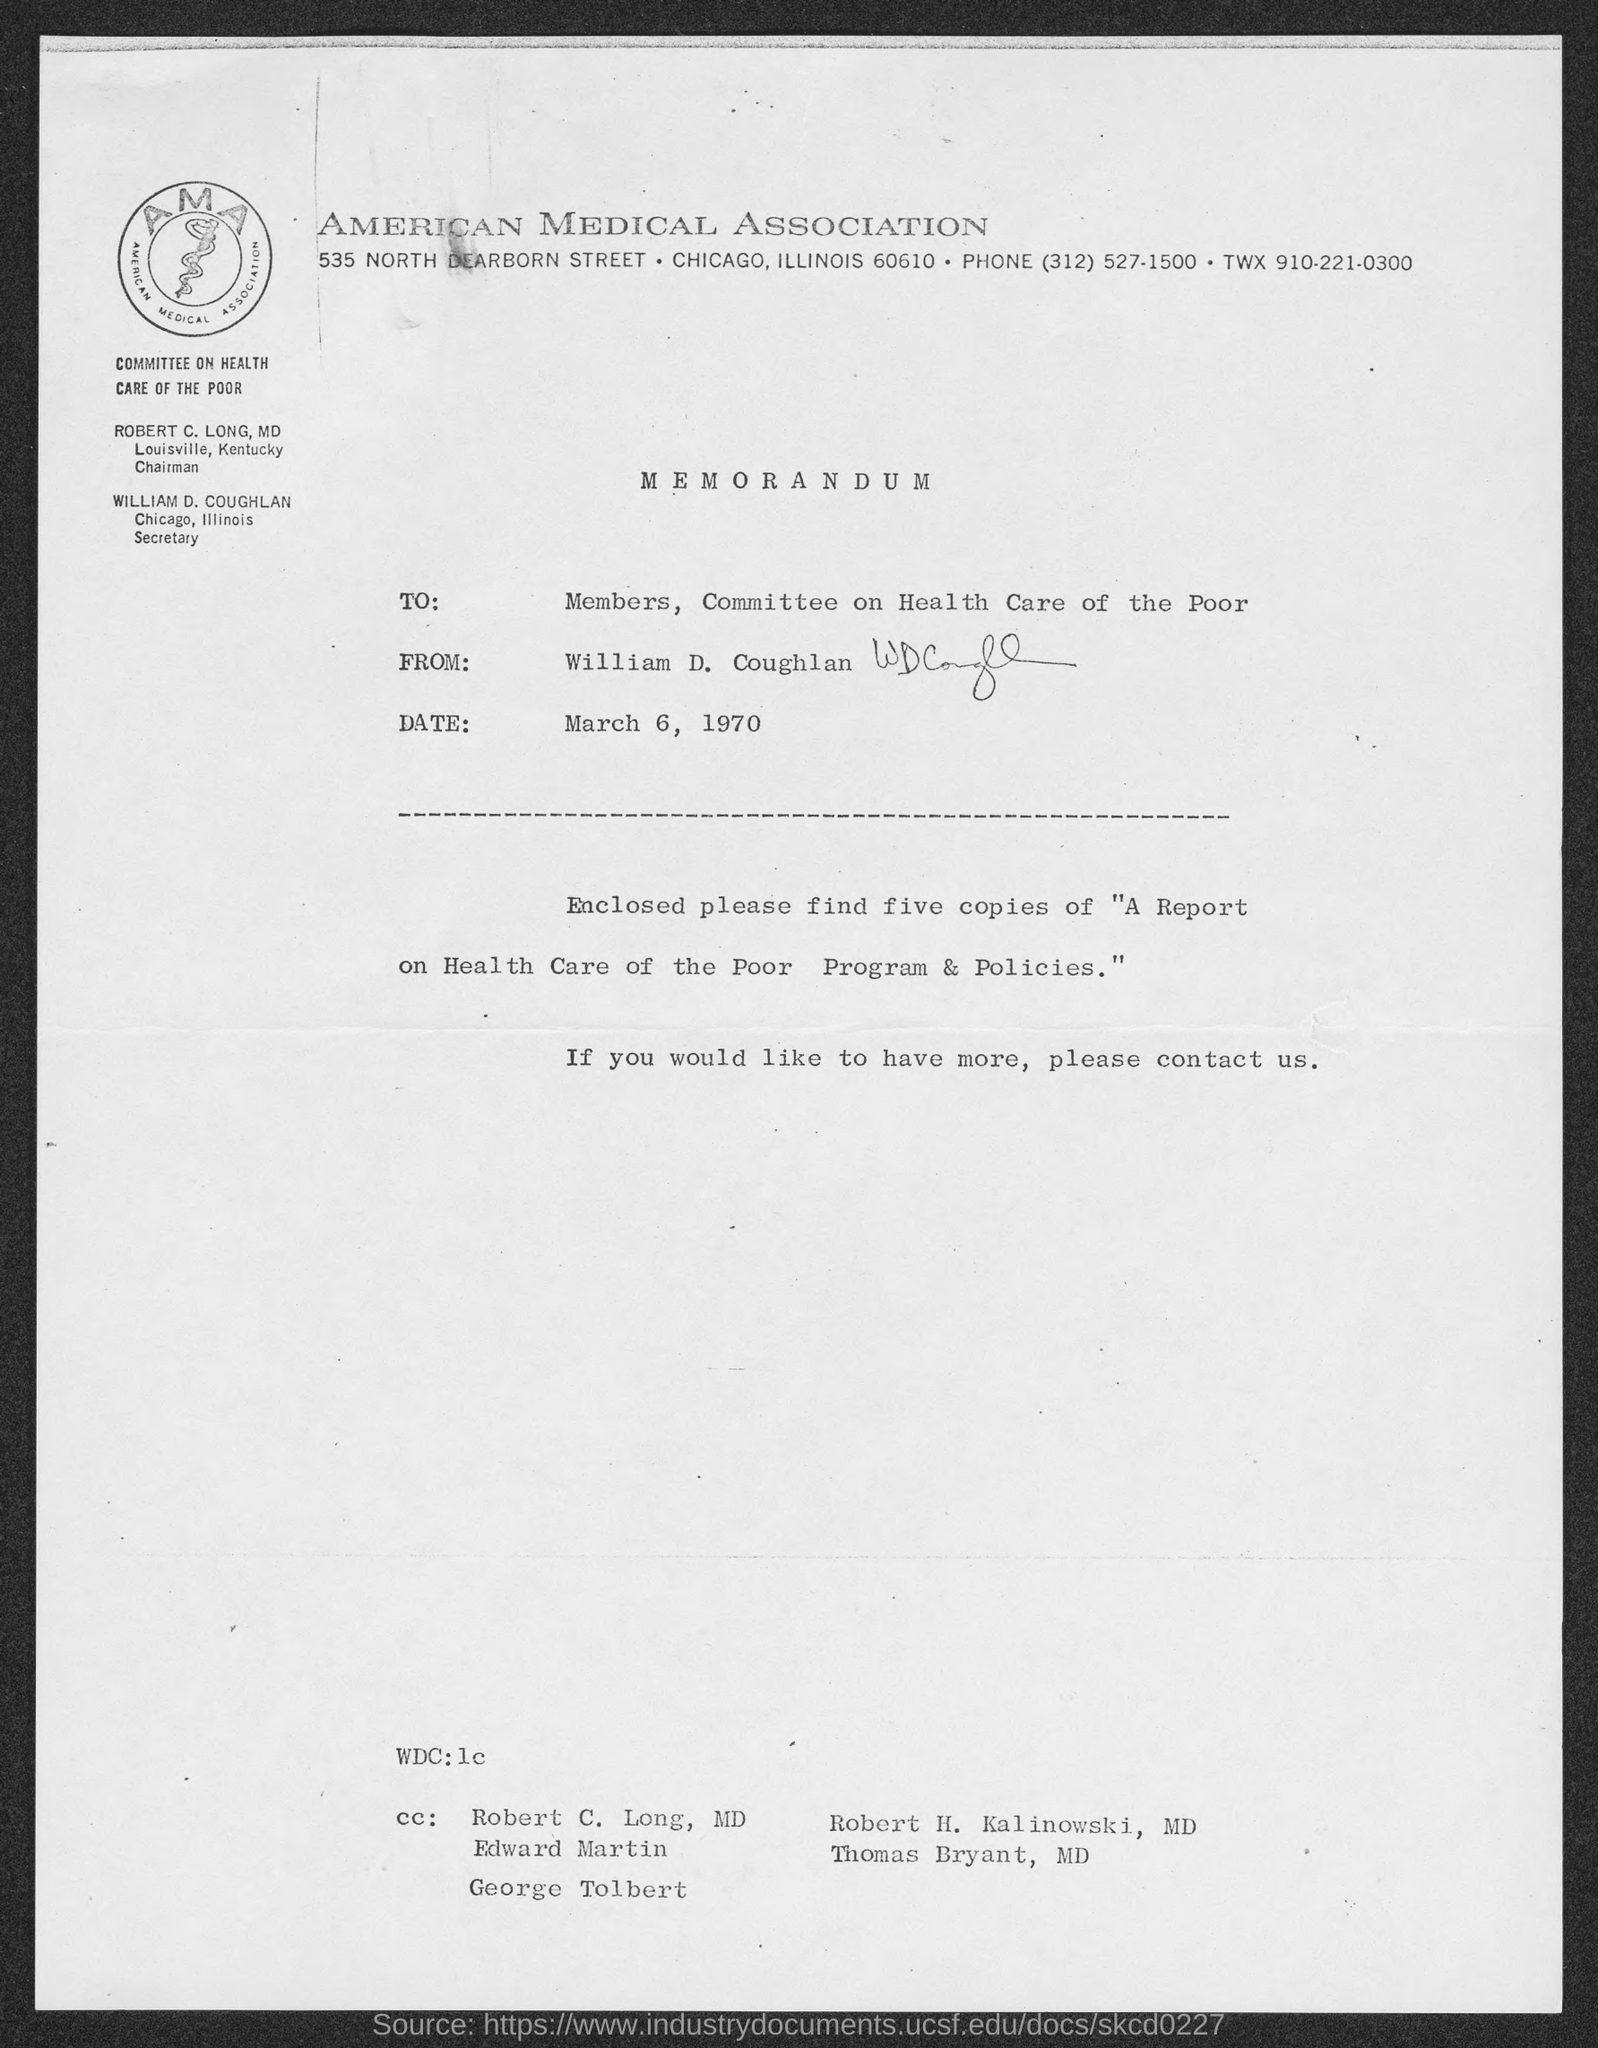Give some essential details in this illustration. The Chairman of the Committee on Health Care of the Poor is Robert C. Long, MD. The memorandum indicates that the date mentioned is March 6, 1970. 